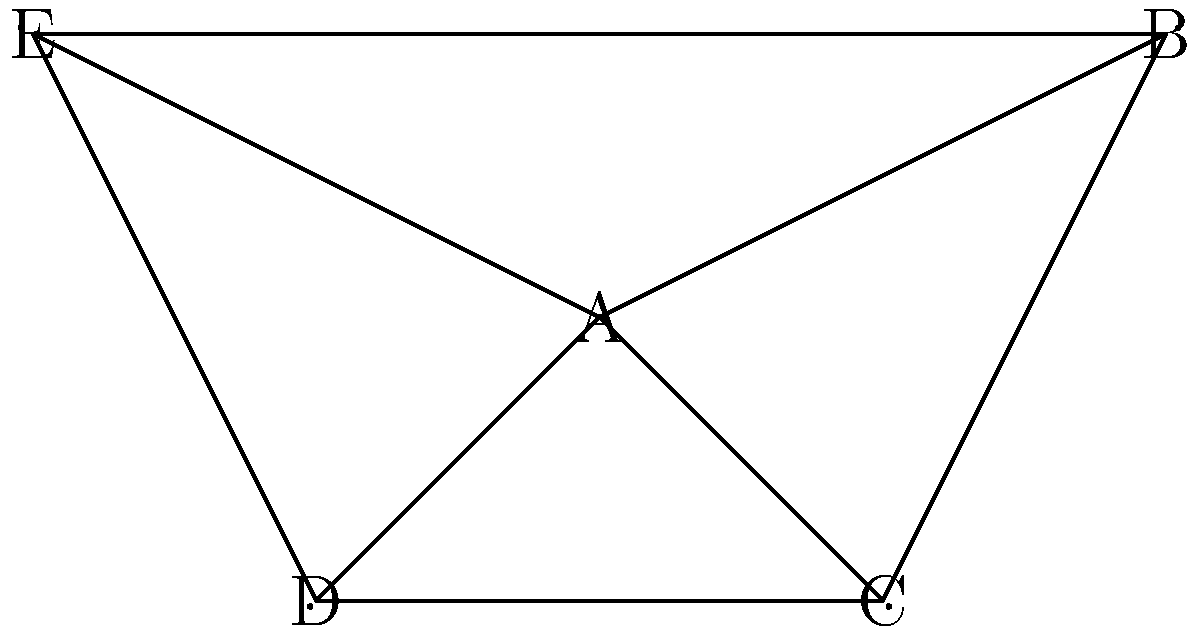In this gossip network, which node is the most influential drama-stirrer based on its degree centrality and betweenness centrality? Explain your reasoning and calculate the centrality measures for the most influential node. To determine the most influential drama-stirring node, we need to calculate both degree centrality and betweenness centrality for each node:

1. Degree Centrality:
   - Node A: 4 connections
   - Nodes B, C, D, E: 3 connections each

   Node A has the highest degree centrality.

2. Betweenness Centrality:
   We need to count the number of shortest paths passing through each node.

   - Node A is on 6 shortest paths: B-D, B-E, C-E, C-D, D-E, B-C
   - Nodes B, C, D, E are each on 0 shortest paths between other nodes

   Node A has the highest betweenness centrality.

3. Calculations for Node A:
   - Degree Centrality: $C_D(A) = \frac{deg(A)}{n-1} = \frac{4}{4} = 1$
   - Betweenness Centrality: $C_B(A) = \frac{2 * 6}{(n-1)(n-2)} = \frac{12}{12} = 1$

   where $n$ is the number of nodes (5 in this case).

Node A has both the highest degree centrality and betweenness centrality, making it the most influential drama-stirrer in the network. It has direct connections to all other nodes and controls the flow of information between them.
Answer: Node A 